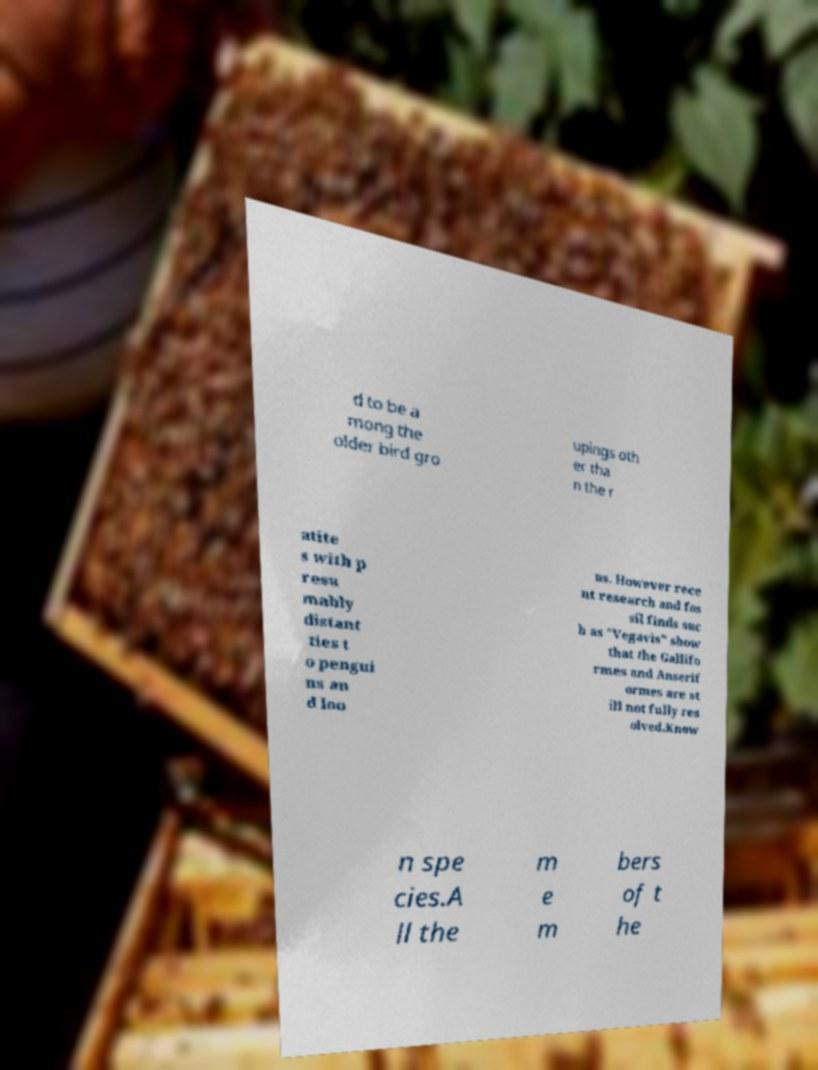What messages or text are displayed in this image? I need them in a readable, typed format. d to be a mong the older bird gro upings oth er tha n the r atite s with p resu mably distant ties t o pengui ns an d loo ns. However rece nt research and fos sil finds suc h as "Vegavis" show that the Gallifo rmes and Anserif ormes are st ill not fully res olved.Know n spe cies.A ll the m e m bers of t he 